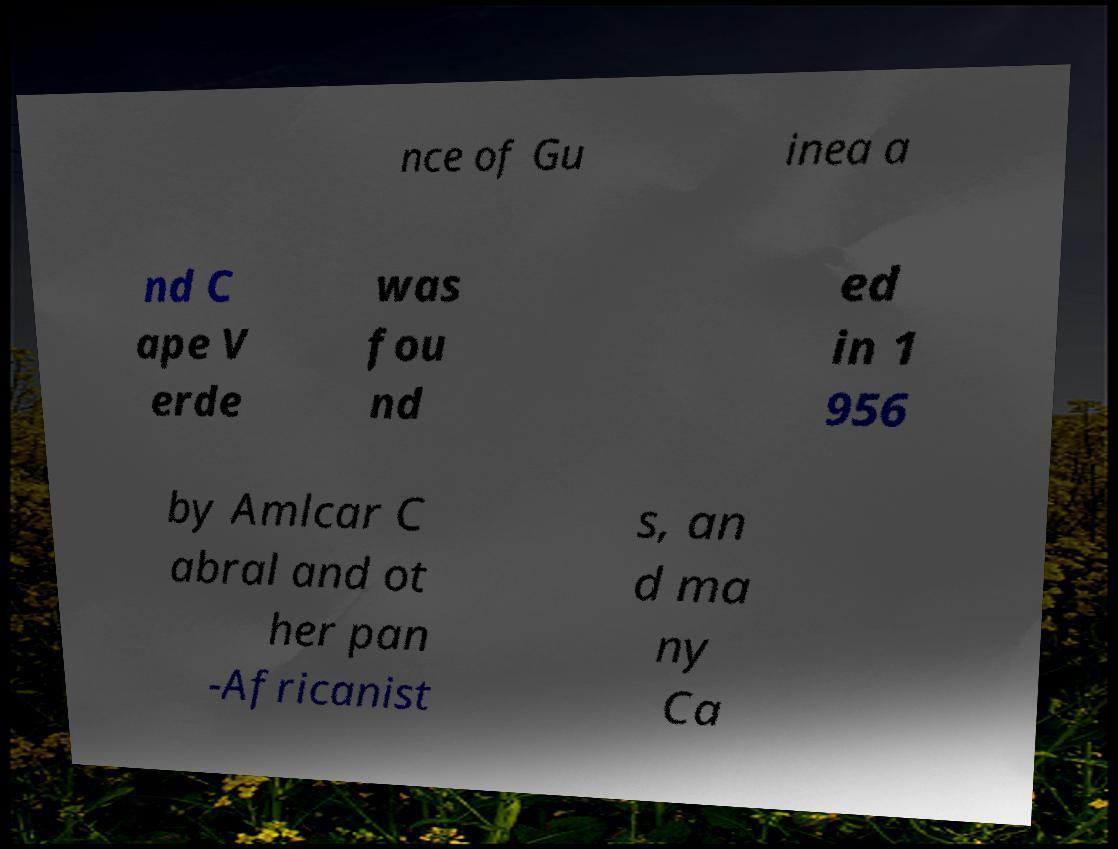Please read and relay the text visible in this image. What does it say? nce of Gu inea a nd C ape V erde was fou nd ed in 1 956 by Amlcar C abral and ot her pan -Africanist s, an d ma ny Ca 